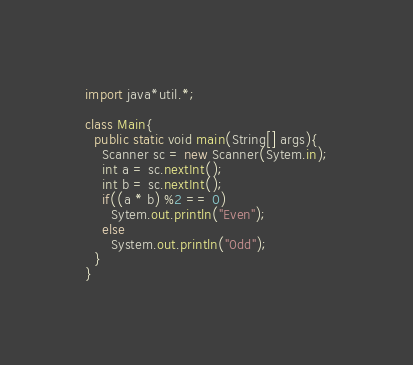<code> <loc_0><loc_0><loc_500><loc_500><_Java_>import java*util.*;

class Main{
  public static void main(String[] args){
    Scanner sc = new Scanner(Sytem.in);
    int a = sc.nextInt();
    int b = sc.nextInt();
    if((a * b) %2 == 0)
      Sytem.out.println("Even");
    else
      System.out.println("0dd");
  }
}</code> 